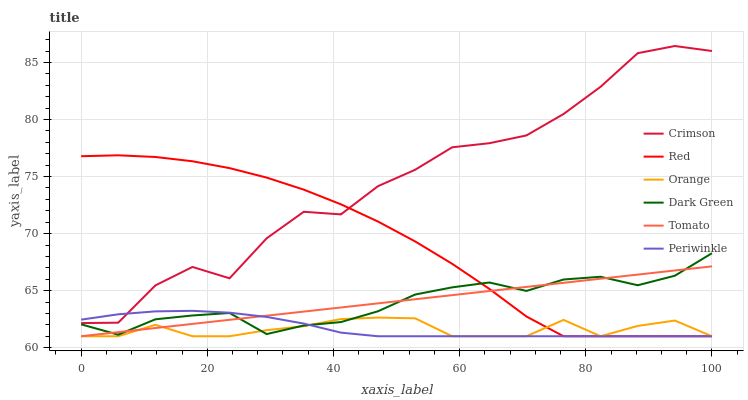Does Orange have the minimum area under the curve?
Answer yes or no. Yes. Does Crimson have the maximum area under the curve?
Answer yes or no. Yes. Does Periwinkle have the minimum area under the curve?
Answer yes or no. No. Does Periwinkle have the maximum area under the curve?
Answer yes or no. No. Is Tomato the smoothest?
Answer yes or no. Yes. Is Crimson the roughest?
Answer yes or no. Yes. Is Orange the smoothest?
Answer yes or no. No. Is Orange the roughest?
Answer yes or no. No. Does Tomato have the lowest value?
Answer yes or no. Yes. Does Crimson have the lowest value?
Answer yes or no. No. Does Crimson have the highest value?
Answer yes or no. Yes. Does Periwinkle have the highest value?
Answer yes or no. No. Is Orange less than Crimson?
Answer yes or no. Yes. Is Crimson greater than Orange?
Answer yes or no. Yes. Does Crimson intersect Red?
Answer yes or no. Yes. Is Crimson less than Red?
Answer yes or no. No. Is Crimson greater than Red?
Answer yes or no. No. Does Orange intersect Crimson?
Answer yes or no. No. 